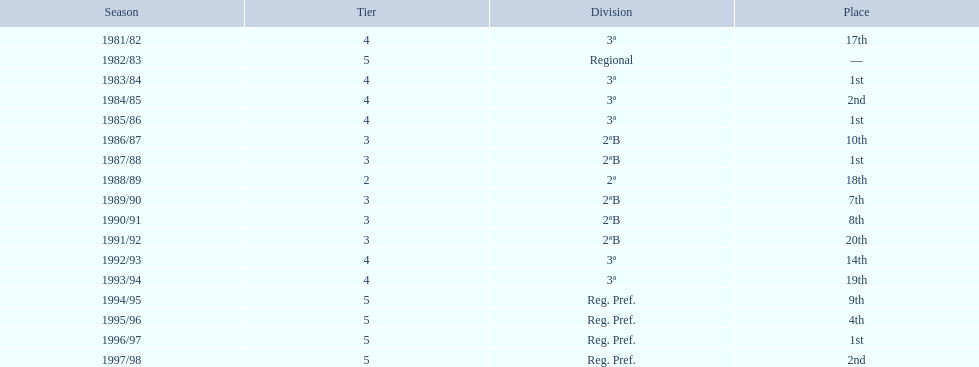How many times total did they finish first 4. 